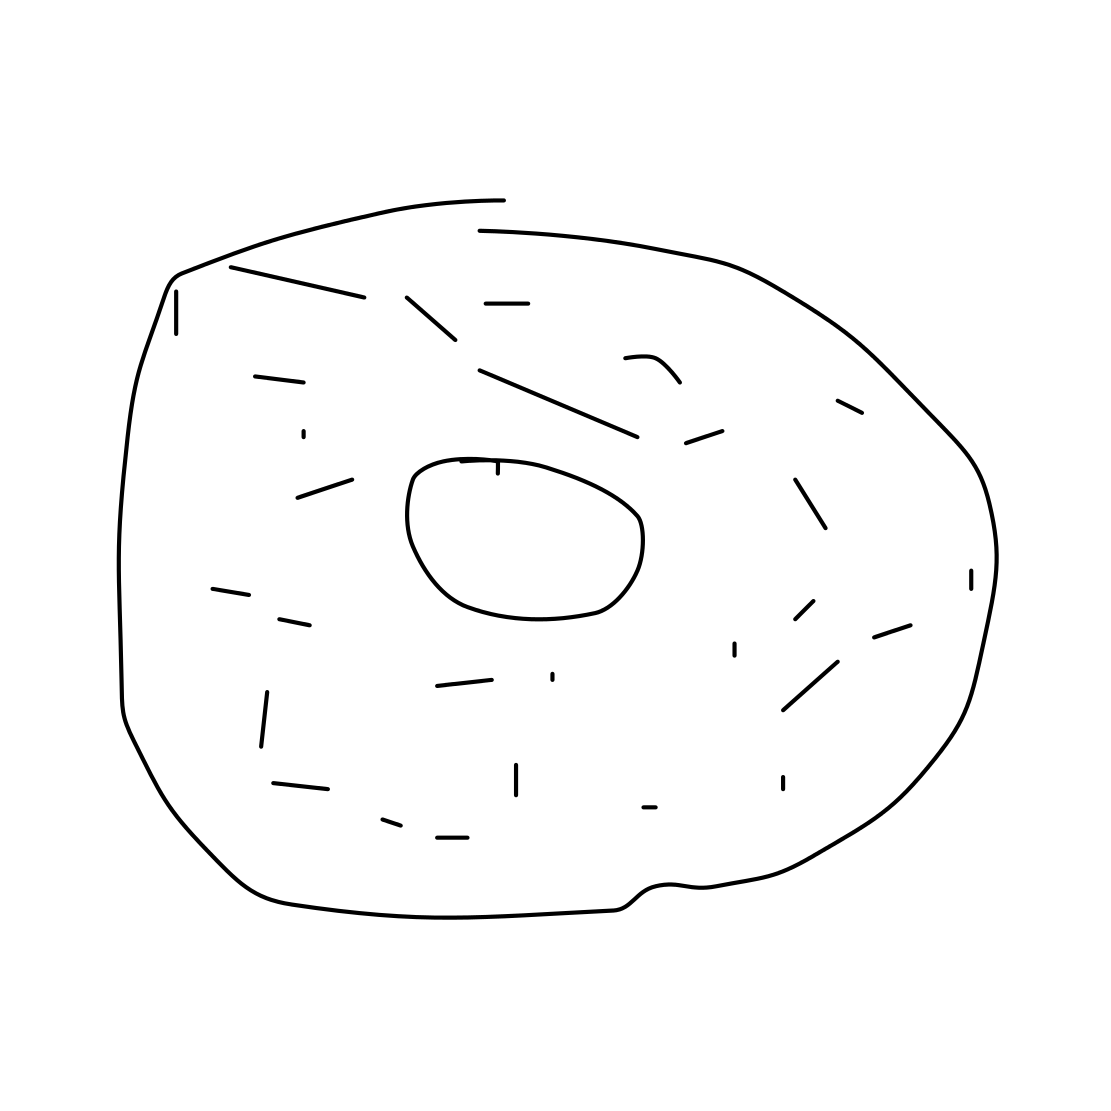Could you tell me what flavor this donut might be? Based on the image, as it's a simple line drawing without color or shading, it's not possible to determine the flavor just from the visual representation. However, we can imagine it might be a classic flavor like plain, sugar-glazed, or even chocolate! 